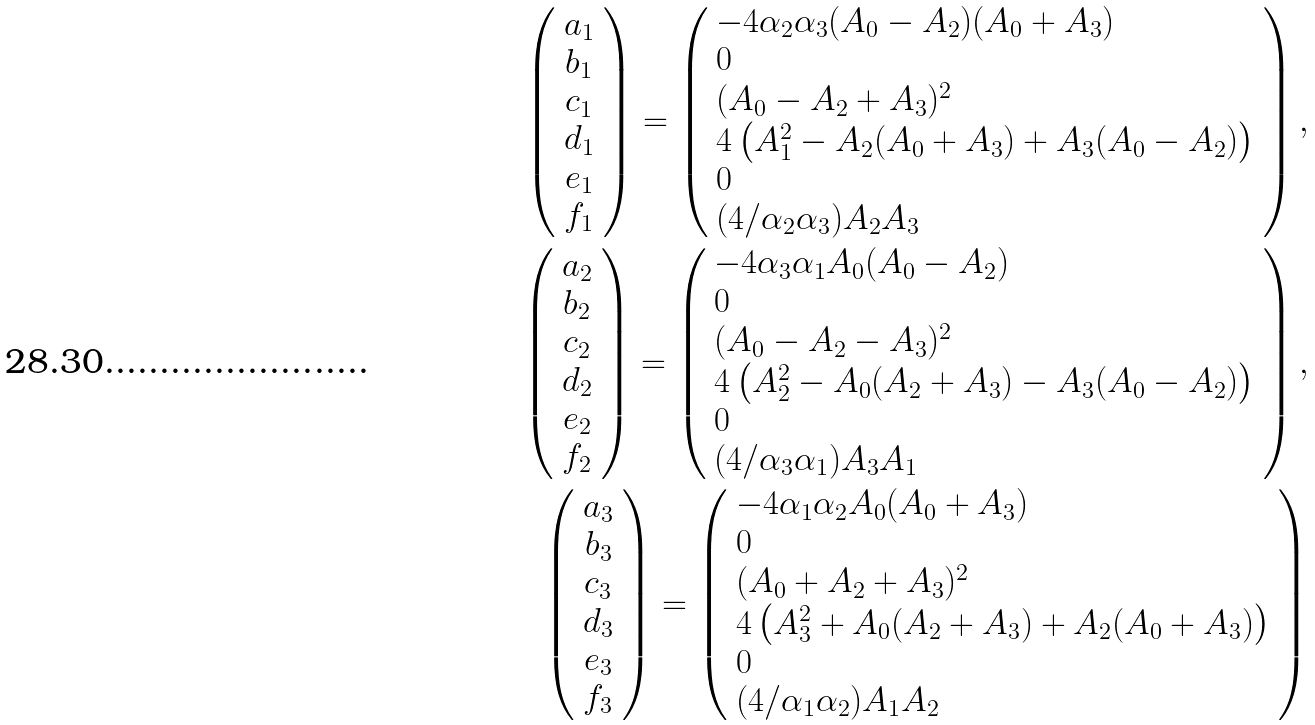Convert formula to latex. <formula><loc_0><loc_0><loc_500><loc_500>\left ( \begin{array} { c } a _ { 1 } \\ b _ { 1 } \\ c _ { 1 } \\ d _ { 1 } \\ e _ { 1 } \\ f _ { 1 } \\ \end{array} \right ) = \left ( \begin{array} { l } - 4 \alpha _ { 2 } \alpha _ { 3 } ( A _ { 0 } - A _ { 2 } ) ( A _ { 0 } + A _ { 3 } ) \\ 0 \\ ( A _ { 0 } - A _ { 2 } + A _ { 3 } ) ^ { 2 } \\ 4 \left ( A _ { 1 } ^ { 2 } - A _ { 2 } ( A _ { 0 } + A _ { 3 } ) + A _ { 3 } ( A _ { 0 } - A _ { 2 } ) \right ) \\ 0 \\ ( 4 / \alpha _ { 2 } \alpha _ { 3 } ) A _ { 2 } A _ { 3 } \\ \end{array} \right ) , \\ \left ( \begin{array} { c } a _ { 2 } \\ b _ { 2 } \\ c _ { 2 } \\ d _ { 2 } \\ e _ { 2 } \\ f _ { 2 } \\ \end{array} \right ) = \left ( \begin{array} { l } - 4 \alpha _ { 3 } \alpha _ { 1 } A _ { 0 } ( A _ { 0 } - A _ { 2 } ) \\ 0 \\ ( A _ { 0 } - A _ { 2 } - A _ { 3 } ) ^ { 2 } \\ 4 \left ( A _ { 2 } ^ { 2 } - A _ { 0 } ( A _ { 2 } + A _ { 3 } ) - A _ { 3 } ( A _ { 0 } - A _ { 2 } ) \right ) \\ 0 \\ ( 4 / \alpha _ { 3 } \alpha _ { 1 } ) A _ { 3 } A _ { 1 } \\ \end{array} \right ) , \\ \left ( \begin{array} { c } a _ { 3 } \\ b _ { 3 } \\ c _ { 3 } \\ d _ { 3 } \\ e _ { 3 } \\ f _ { 3 } \\ \end{array} \right ) = \left ( \begin{array} { l } - 4 \alpha _ { 1 } \alpha _ { 2 } A _ { 0 } ( A _ { 0 } + A _ { 3 } ) \\ 0 \\ ( A _ { 0 } + A _ { 2 } + A _ { 3 } ) ^ { 2 } \\ 4 \left ( A _ { 3 } ^ { 2 } + A _ { 0 } ( A _ { 2 } + A _ { 3 } ) + A _ { 2 } ( A _ { 0 } + A _ { 3 } ) \right ) \\ 0 \\ ( 4 / \alpha _ { 1 } \alpha _ { 2 } ) A _ { 1 } A _ { 2 } \\ \end{array} \right )</formula> 